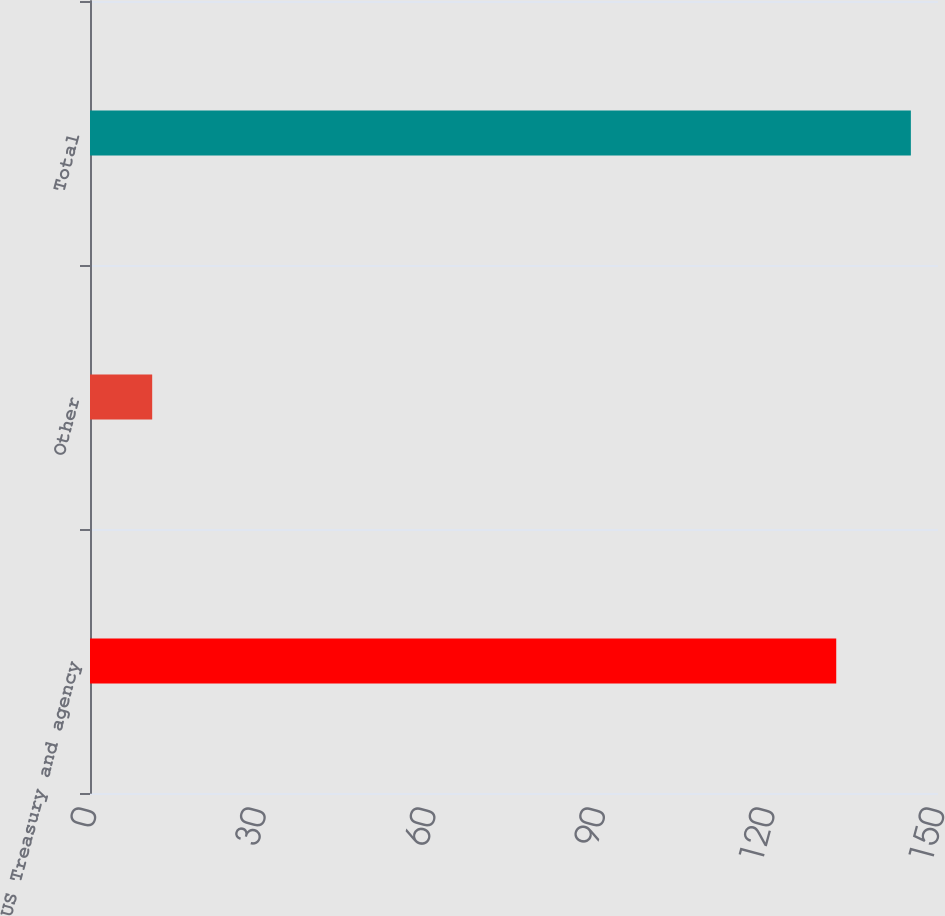Convert chart to OTSL. <chart><loc_0><loc_0><loc_500><loc_500><bar_chart><fcel>US Treasury and agency<fcel>Other<fcel>Total<nl><fcel>132<fcel>11<fcel>145.2<nl></chart> 